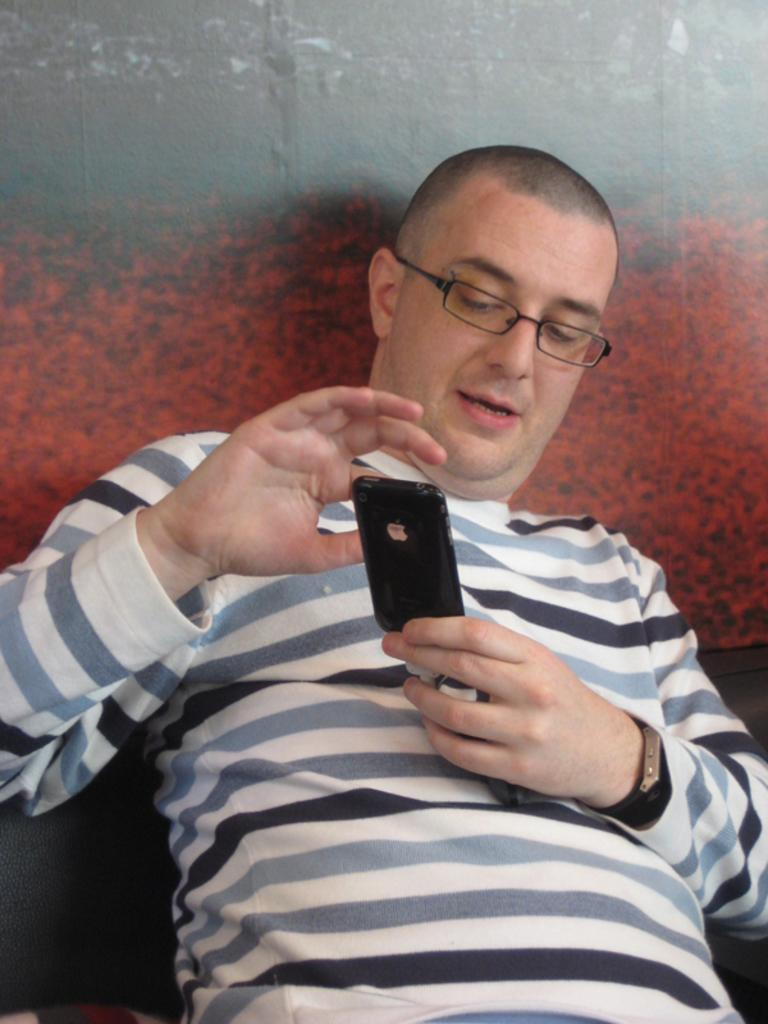What is present in the image? There is a person in the image. What is the person wearing? The person is wearing a T-shirt. What is the person holding in his hand? The person is holding a phone in his hand. What type of slope can be seen in the image? There is no slope present in the image. What mode of transport is the person using in the image? The image does not show the person using any mode of transport. 